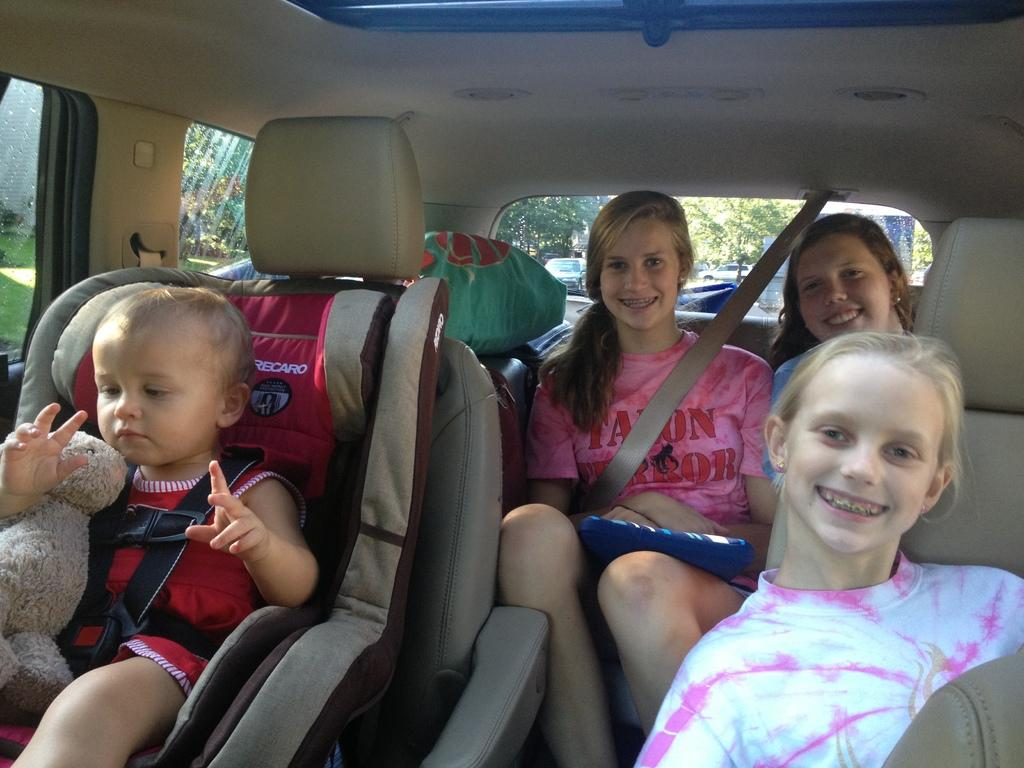What are the people in the image doing? There are people sitting in a vehicle in the image. Can you describe the expressions of the people in the image? Some people have smiles on their faces in the image. What can be seen in the background of the image? There are trees visible in the background of the image. What type of mask is being worn by the people in the image? There is no mention of masks in the image, so it cannot be determined if anyone is wearing a mask. 